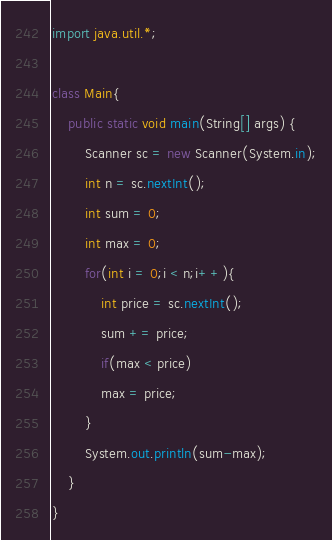Convert code to text. <code><loc_0><loc_0><loc_500><loc_500><_Java_>import java.util.*;

class Main{
    public static void main(String[] args) {
        Scanner sc = new Scanner(System.in);
        int n = sc.nextInt();
        int sum = 0;
        int max = 0;
        for(int i = 0;i < n;i++){
            int price = sc.nextInt();
            sum += price;
            if(max < price)
            max = price;
        }
        System.out.println(sum-max);
    }
}</code> 